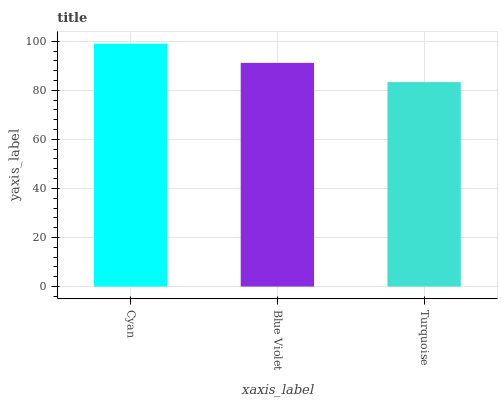Is Turquoise the minimum?
Answer yes or no. Yes. Is Cyan the maximum?
Answer yes or no. Yes. Is Blue Violet the minimum?
Answer yes or no. No. Is Blue Violet the maximum?
Answer yes or no. No. Is Cyan greater than Blue Violet?
Answer yes or no. Yes. Is Blue Violet less than Cyan?
Answer yes or no. Yes. Is Blue Violet greater than Cyan?
Answer yes or no. No. Is Cyan less than Blue Violet?
Answer yes or no. No. Is Blue Violet the high median?
Answer yes or no. Yes. Is Blue Violet the low median?
Answer yes or no. Yes. Is Cyan the high median?
Answer yes or no. No. Is Turquoise the low median?
Answer yes or no. No. 